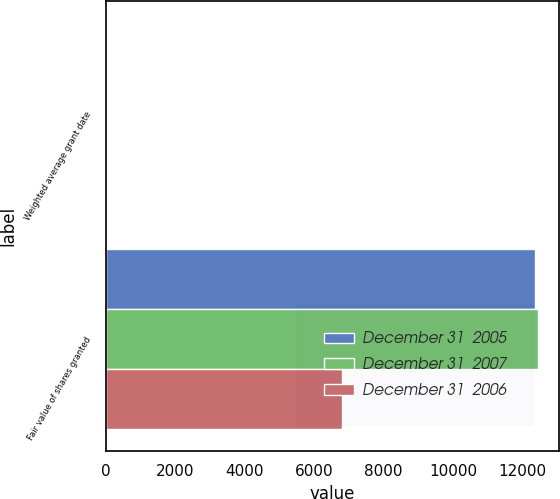Convert chart. <chart><loc_0><loc_0><loc_500><loc_500><stacked_bar_chart><ecel><fcel>Weighted average grant date<fcel>Fair value of shares granted<nl><fcel>December 31  2005<fcel>37.58<fcel>12366<nl><fcel>December 31  2007<fcel>25.98<fcel>12444<nl><fcel>December 31  2006<fcel>25.5<fcel>6804<nl></chart> 